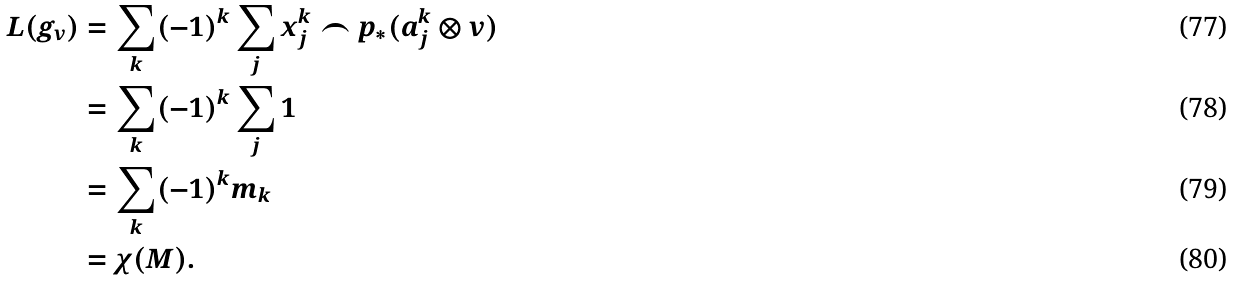Convert formula to latex. <formula><loc_0><loc_0><loc_500><loc_500>L ( g _ { v } ) & = \sum _ { k } ( - 1 ) ^ { k } \sum _ { j } x _ { j } ^ { k } \frown p _ { \ast } ( a _ { j } ^ { k } \otimes v ) \\ & = \sum _ { k } ( - 1 ) ^ { k } \sum _ { j } 1 \\ & = \sum _ { k } ( - 1 ) ^ { k } m _ { k } \\ & = \chi ( M ) .</formula> 